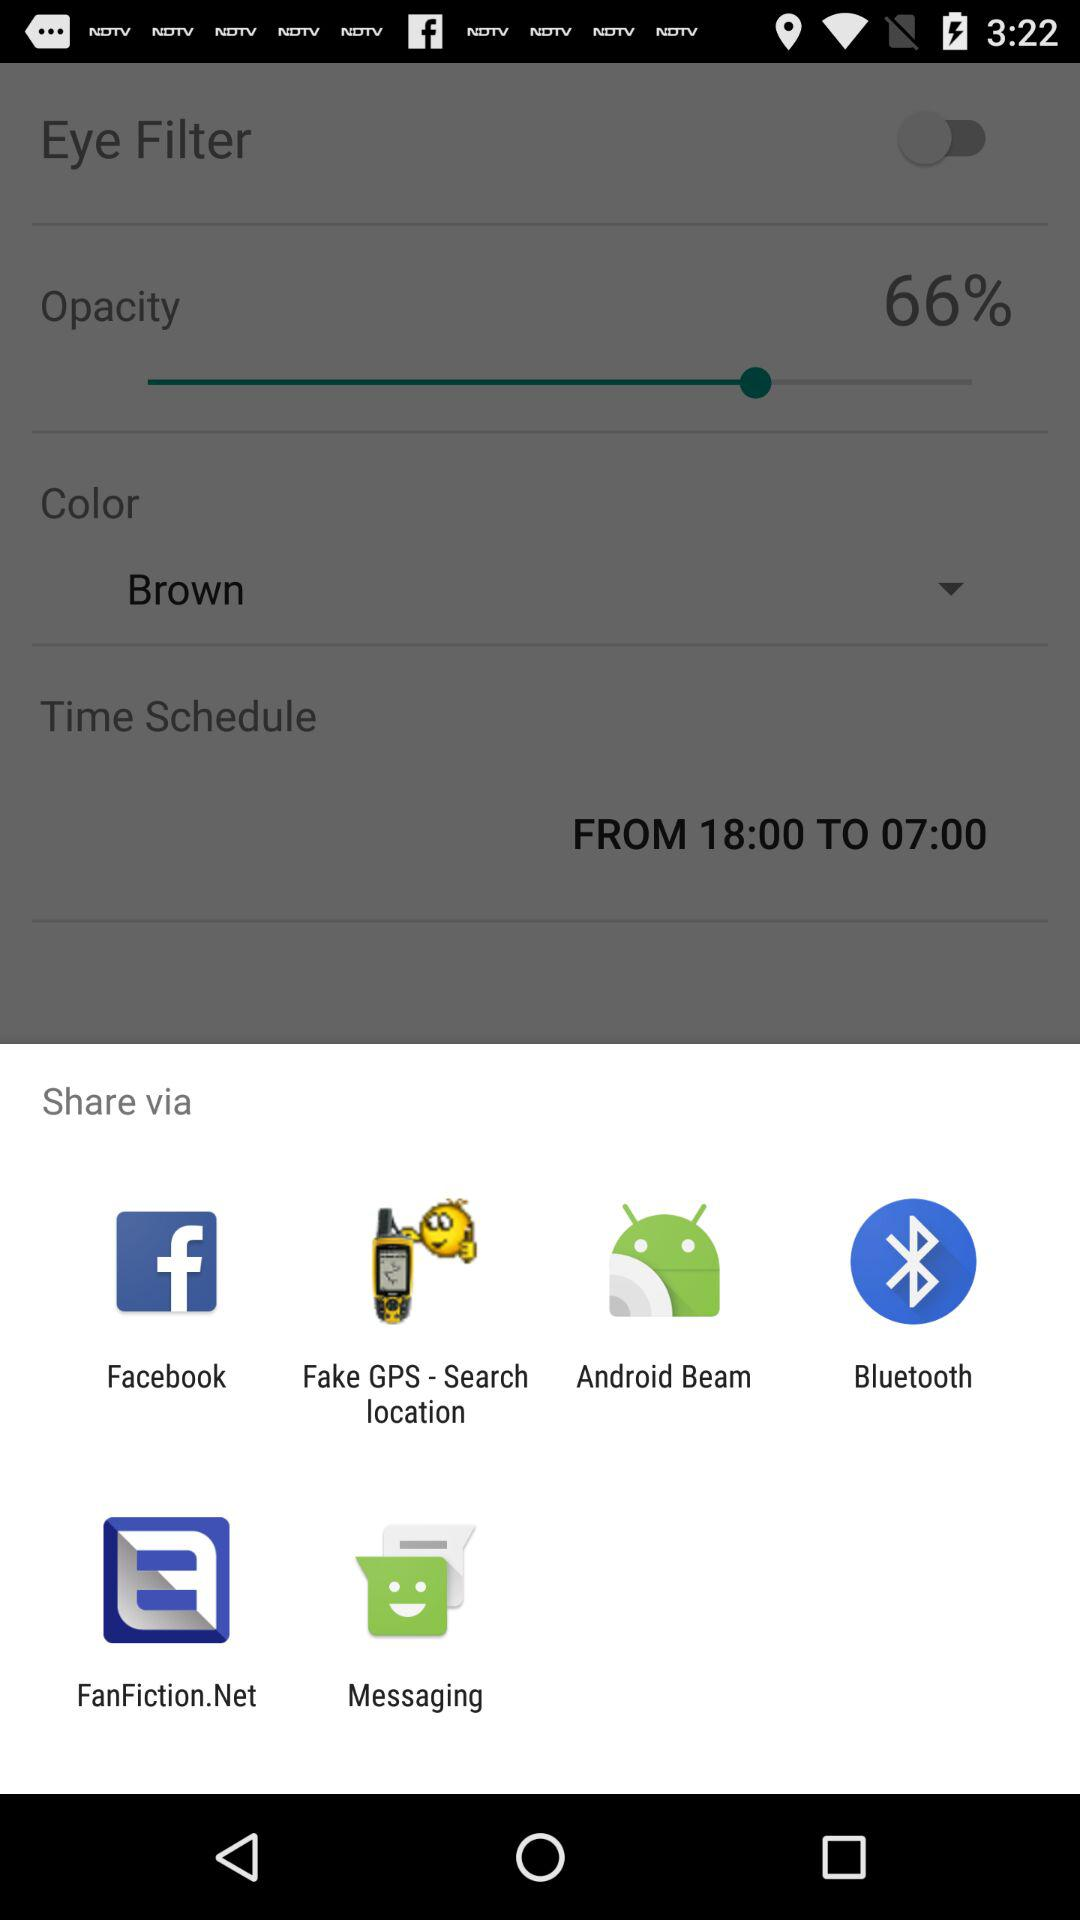What are the sharing options? The sharing options are "Facebook", "Fake GPS - Search location", "Android Beam", "Bluetooth", "FanFiction.Net" and "Messaging". 